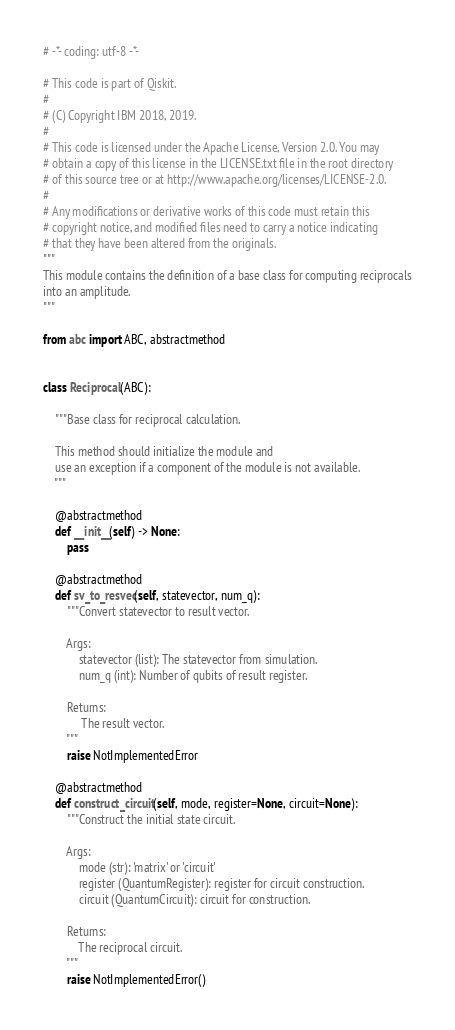<code> <loc_0><loc_0><loc_500><loc_500><_Python_># -*- coding: utf-8 -*-

# This code is part of Qiskit.
#
# (C) Copyright IBM 2018, 2019.
#
# This code is licensed under the Apache License, Version 2.0. You may
# obtain a copy of this license in the LICENSE.txt file in the root directory
# of this source tree or at http://www.apache.org/licenses/LICENSE-2.0.
#
# Any modifications or derivative works of this code must retain this
# copyright notice, and modified files need to carry a notice indicating
# that they have been altered from the originals.
"""
This module contains the definition of a base class for computing reciprocals
into an amplitude.
"""

from abc import ABC, abstractmethod


class Reciprocal(ABC):

    """Base class for reciprocal calculation.

    This method should initialize the module and
    use an exception if a component of the module is not available.
    """

    @abstractmethod
    def __init__(self) -> None:
        pass

    @abstractmethod
    def sv_to_resvec(self, statevector, num_q):
        """Convert statevector to result vector.

        Args:
            statevector (list): The statevector from simulation.
            num_q (int): Number of qubits of result register.

        Returns:
             The result vector.
        """
        raise NotImplementedError

    @abstractmethod
    def construct_circuit(self, mode, register=None, circuit=None):
        """Construct the initial state circuit.

        Args:
            mode (str): 'matrix' or 'circuit'
            register (QuantumRegister): register for circuit construction.
            circuit (QuantumCircuit): circuit for construction.

        Returns:
            The reciprocal circuit.
        """
        raise NotImplementedError()
</code> 